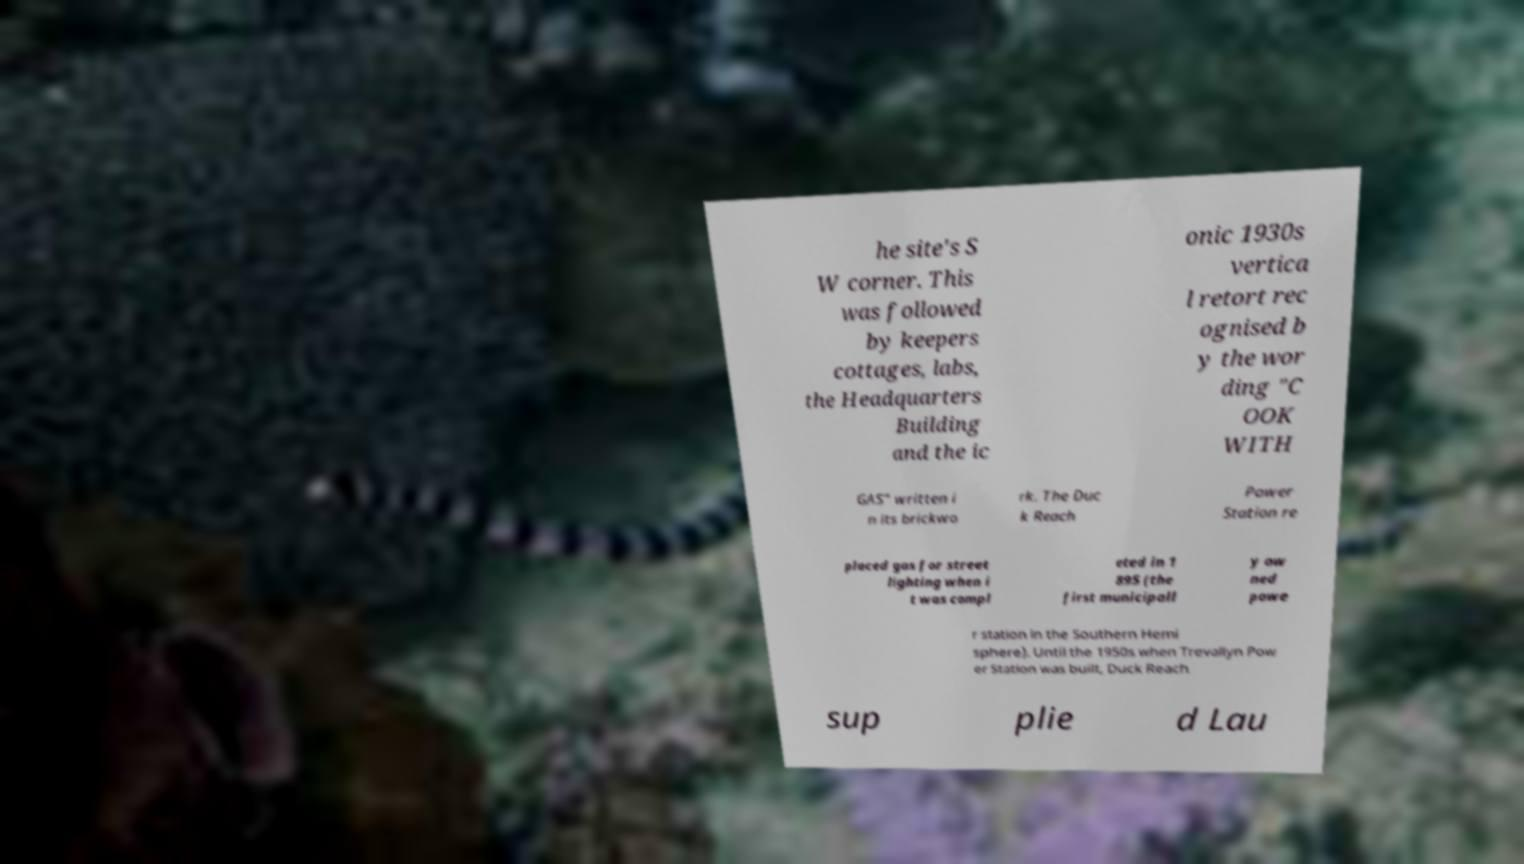Can you accurately transcribe the text from the provided image for me? he site's S W corner. This was followed by keepers cottages, labs, the Headquarters Building and the ic onic 1930s vertica l retort rec ognised b y the wor ding "C OOK WITH GAS" written i n its brickwo rk. The Duc k Reach Power Station re placed gas for street lighting when i t was compl eted in 1 895 (the first municipall y ow ned powe r station in the Southern Hemi sphere). Until the 1950s when Trevallyn Pow er Station was built, Duck Reach sup plie d Lau 